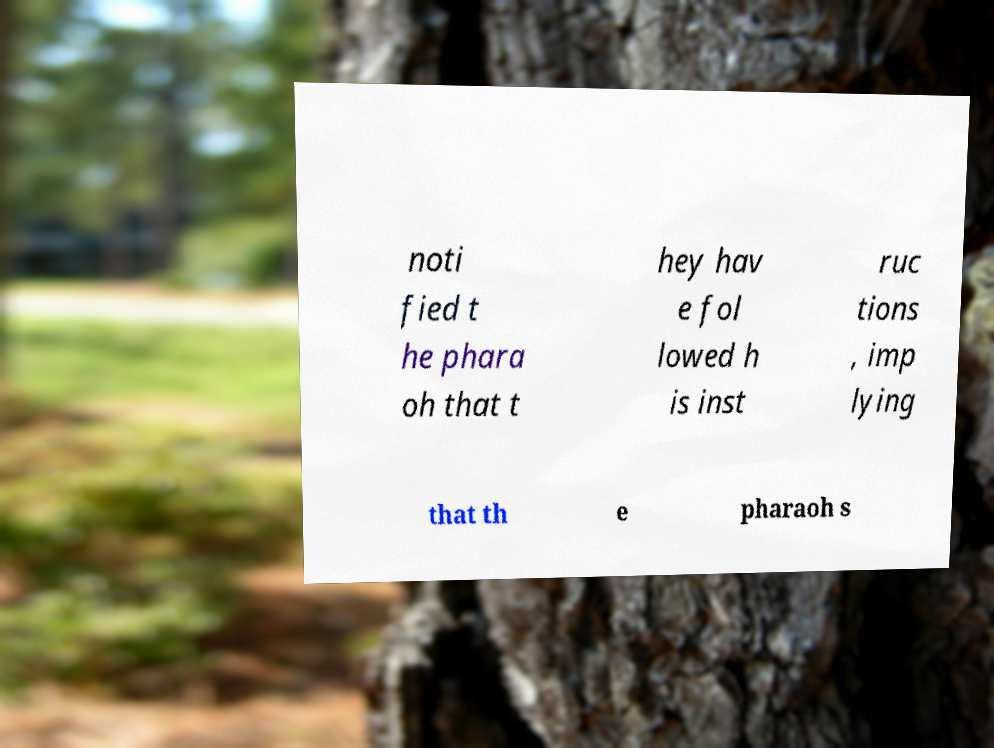What messages or text are displayed in this image? I need them in a readable, typed format. noti fied t he phara oh that t hey hav e fol lowed h is inst ruc tions , imp lying that th e pharaoh s 